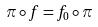<formula> <loc_0><loc_0><loc_500><loc_500>\pi \circ f = f _ { 0 } \circ \pi</formula> 